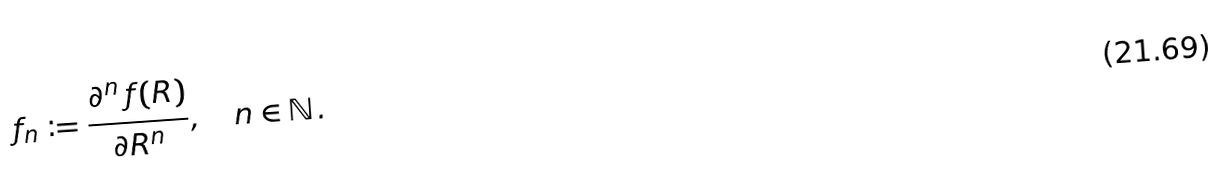<formula> <loc_0><loc_0><loc_500><loc_500>f _ { n } \coloneqq \frac { \partial ^ { n } \, f ( R ) } { \partial R ^ { n } } , \quad n \in \mathbb { N } \, .</formula> 